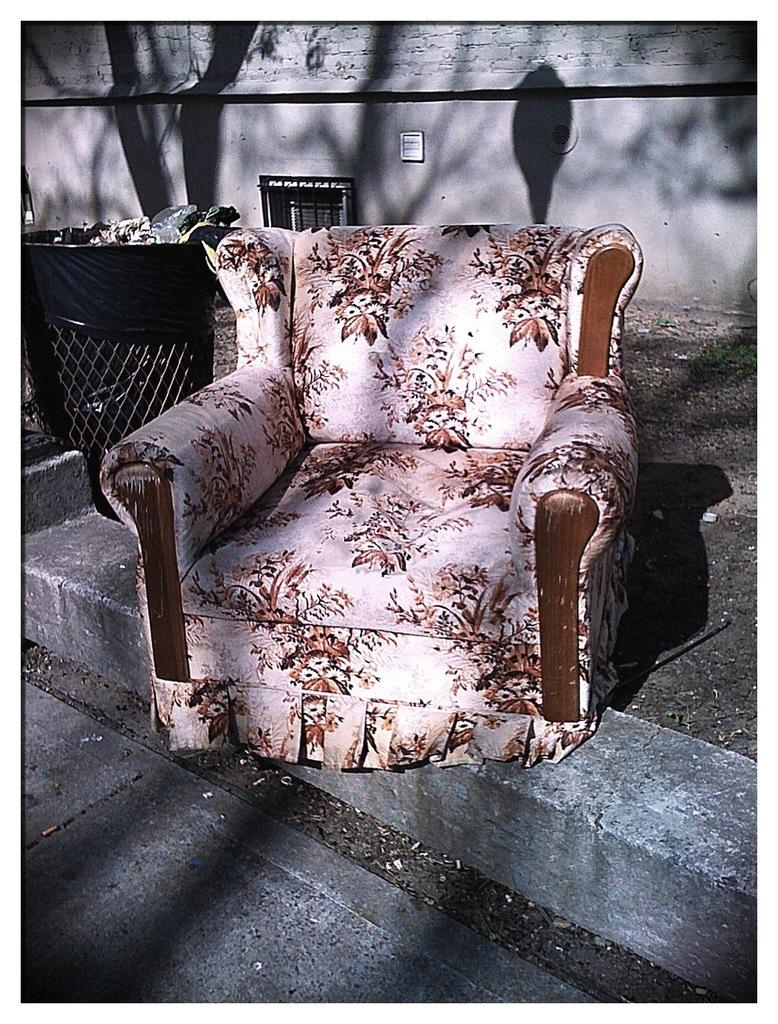What type of furniture is present in the image? There is a white and brown sofa chair in the image. What can be observed in relation to the lighting in the image? Shadows are visible in the image. What is the purpose of the object located near the sofa chair? There is a dustbin in the image, which is typically used for disposing of waste. What is visible in the background of the image? The background of the image includes a wall. Can you describe the motion of the hen in the image? There is no hen present in the image, so it is not possible to describe its motion. 